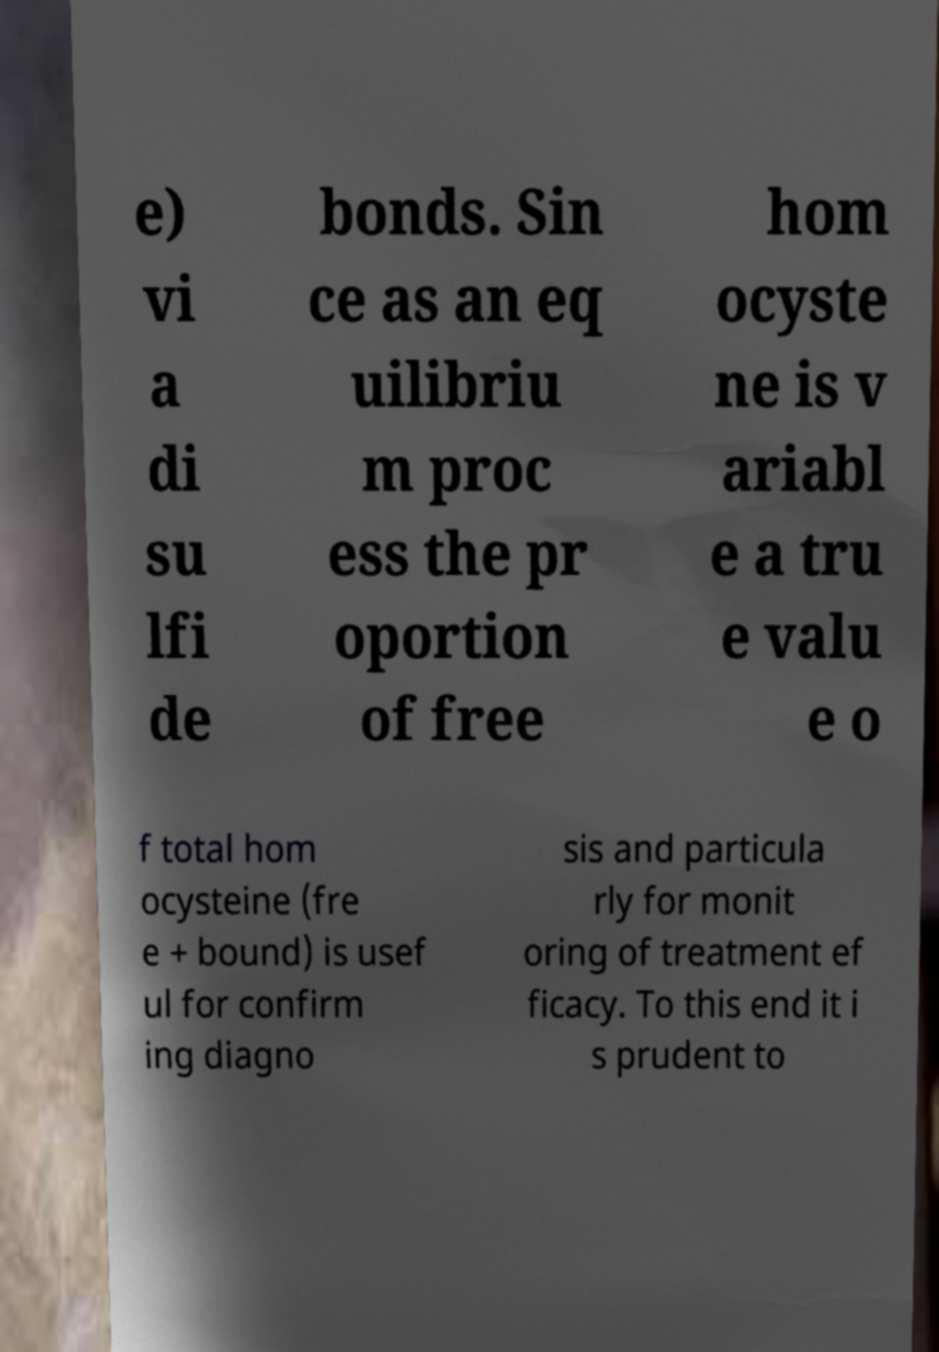Can you accurately transcribe the text from the provided image for me? e) vi a di su lfi de bonds. Sin ce as an eq uilibriu m proc ess the pr oportion of free hom ocyste ne is v ariabl e a tru e valu e o f total hom ocysteine (fre e + bound) is usef ul for confirm ing diagno sis and particula rly for monit oring of treatment ef ficacy. To this end it i s prudent to 